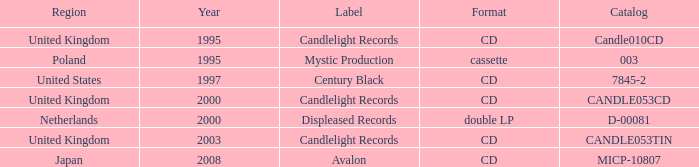Can you parse all the data within this table? {'header': ['Region', 'Year', 'Label', 'Format', 'Catalog'], 'rows': [['United Kingdom', '1995', 'Candlelight Records', 'CD', 'Candle010CD'], ['Poland', '1995', 'Mystic Production', 'cassette', '003'], ['United States', '1997', 'Century Black', 'CD', '7845-2'], ['United Kingdom', '2000', 'Candlelight Records', 'CD', 'CANDLE053CD'], ['Netherlands', '2000', 'Displeased Records', 'double LP', 'D-00081'], ['United Kingdom', '2003', 'Candlelight Records', 'CD', 'CANDLE053TIN'], ['Japan', '2008', 'Avalon', 'CD', 'MICP-10807']]} In which format does candlelight records operate? CD, CD, CD. 